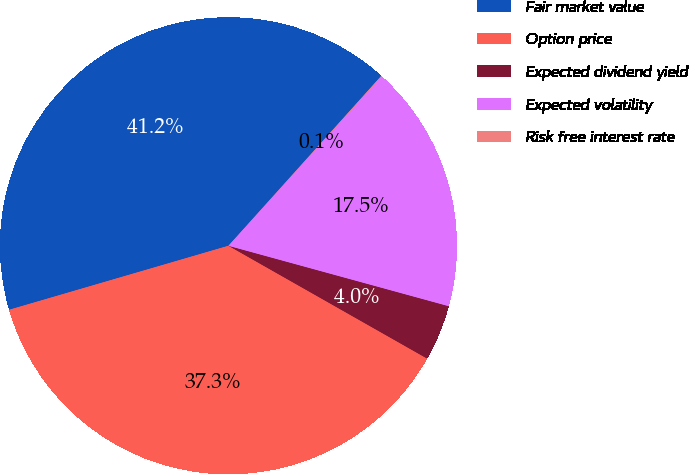Convert chart. <chart><loc_0><loc_0><loc_500><loc_500><pie_chart><fcel>Fair market value<fcel>Option price<fcel>Expected dividend yield<fcel>Expected volatility<fcel>Risk free interest rate<nl><fcel>41.18%<fcel>37.26%<fcel>3.96%<fcel>17.55%<fcel>0.05%<nl></chart> 